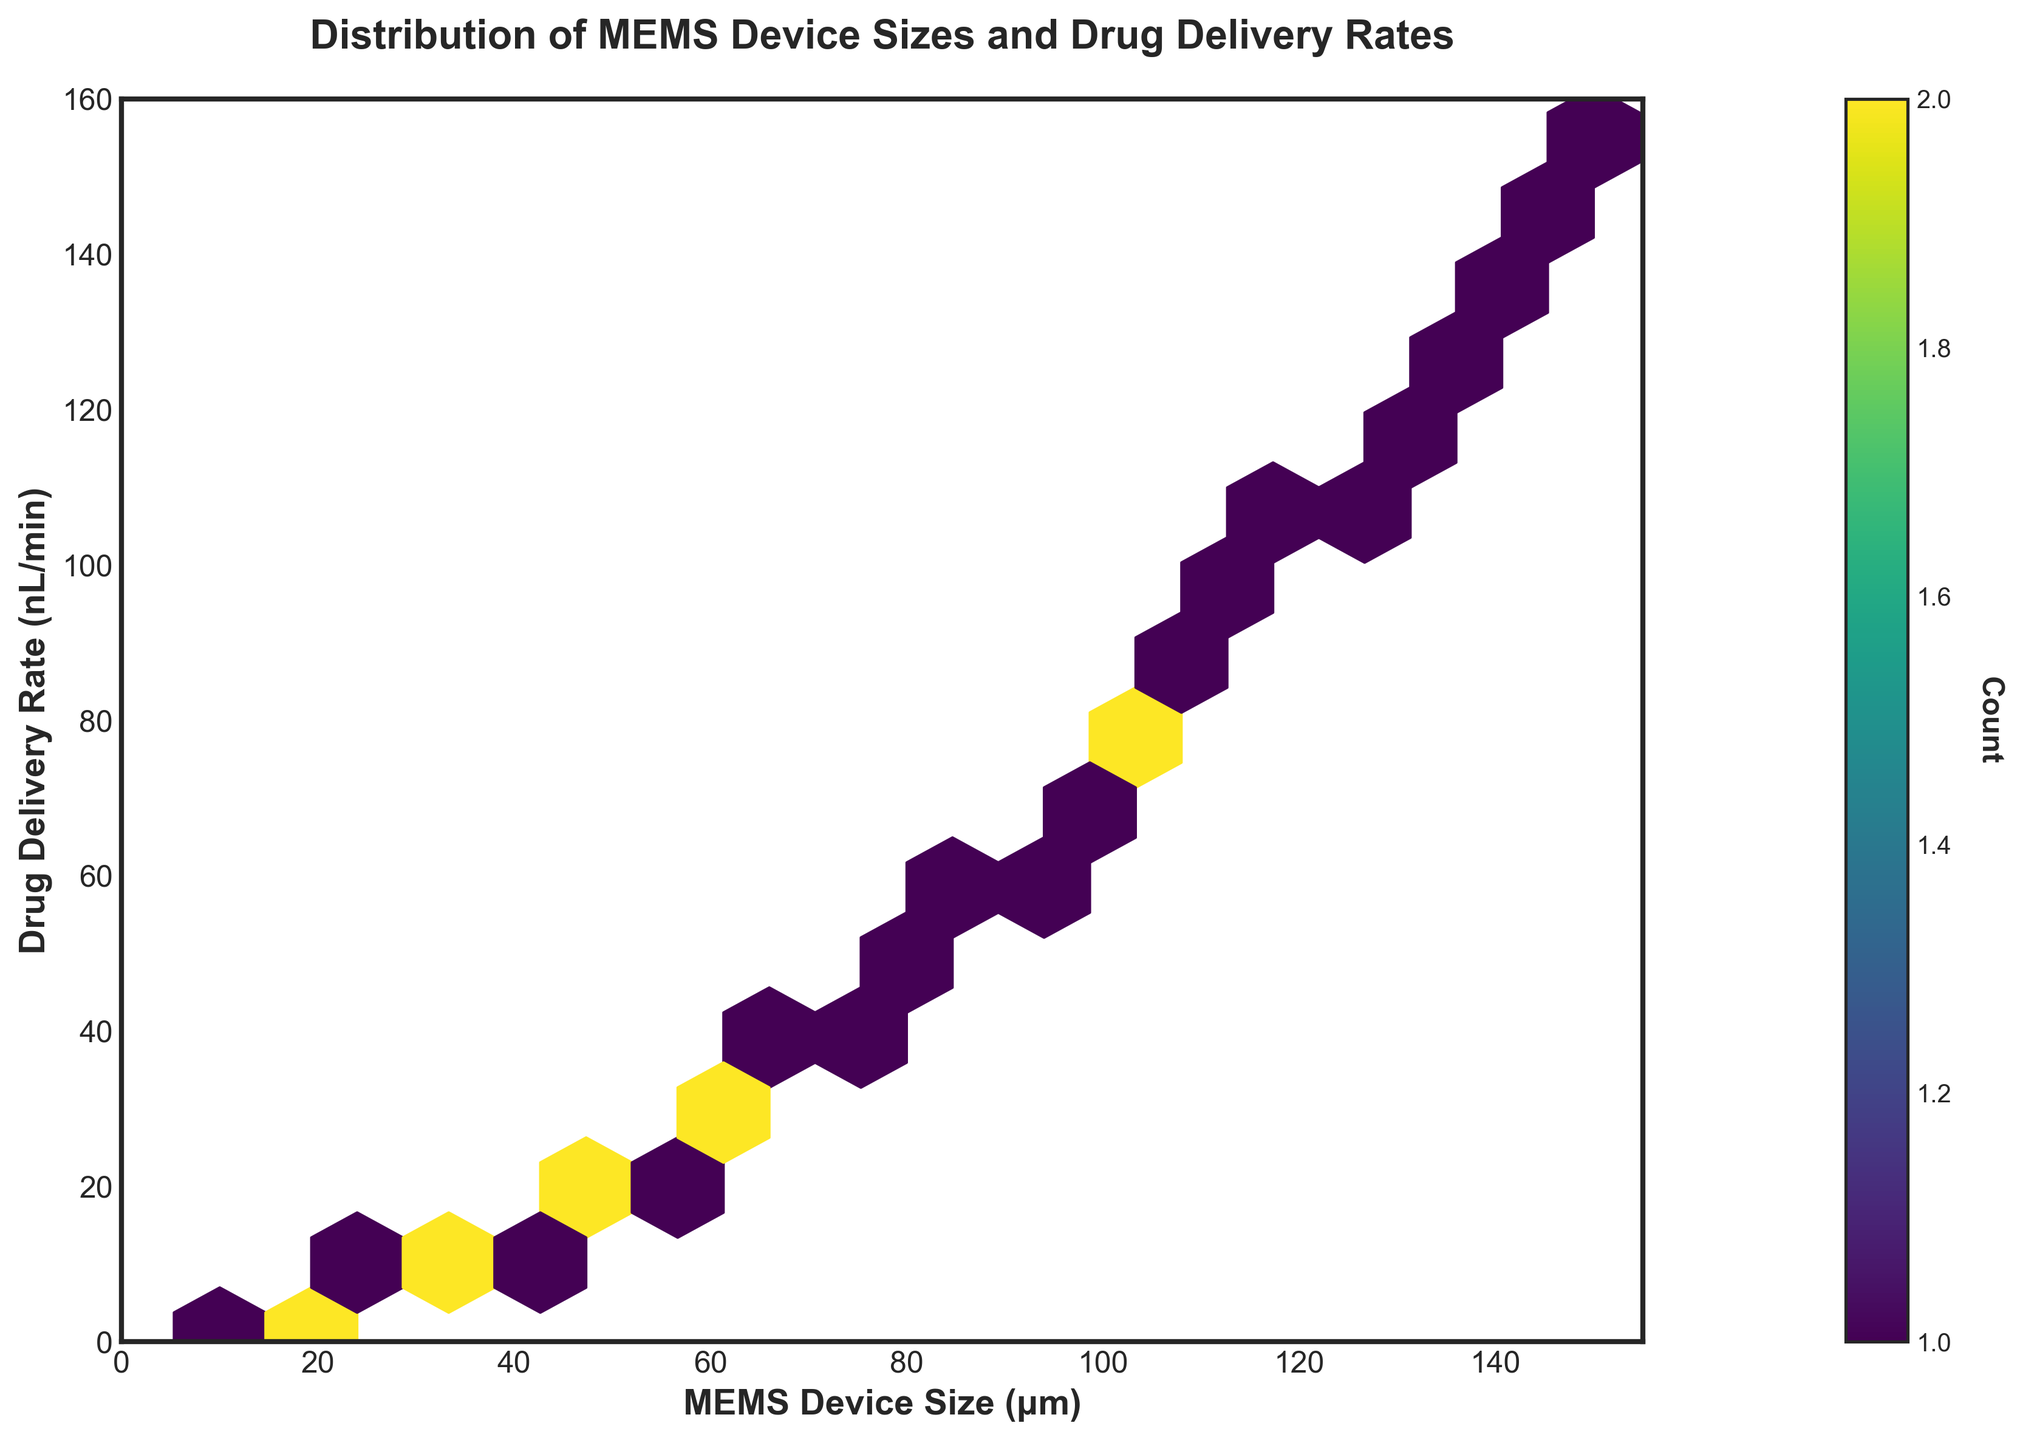What is the title of the plot? The title is usually displayed at the top of the plot. In this case, the title reads "Distribution of MEMS Device Sizes and Drug Delivery Rates".
Answer: Distribution of MEMS Device Sizes and Drug Delivery Rates What are the labels on the axes? The x-axis label can be found horizontally along the bottom, and the y-axis label runs vertically along the side. Here, the x-axis is labeled "MEMS Device Size (μm)" and the y-axis is labeled "Drug Delivery Rate (nL/min)".
Answer: MEMS Device Size (μm) and Drug Delivery Rate (nL/min) What is the color used for the hexbins, and what does it represent? The color map used is viridis, which displays a range from dark blue to bright yellow. The color intensity represents the count of data points within each hexbin.
Answer: Viridis, representing the count of data points Which size and delivery rate combination is most common in this dataset? By observing the highest intensity color (bright yellow) in the hexbin plot, we can identify the hexbin with the highest count. Let's assume it's around the size range of 50-55 μm and the rate range of 19-24 nL/min.
Answer: Around 50-55 μm and 19-24 nL/min Is there a general trend in the relationship between MEMS device size and drug delivery rate? The plot shows a progressive increase in drug delivery rate as the MEMS device size increases, indicating a positive correlation.
Answer: Positive correlation What is the drug delivery rate when the MEMS device size is about 100 μm? Locate the x-axis at approximately 100 μm and find the corresponding vertical range of the hexbin plot. The rate appears to be around 74.5 nL/min.
Answer: Around 74.5 nL/min Which is higher, the drug delivery rate for 30 μm or for 90 μm MEMS devices? Compare the vertical positions corresponding to 30 μm and 90 μm on the x-axis. The rate for 90 μm (around 61.3 nL/min) is higher than for 30 μm (around 6.7 nL/min).
Answer: 90 μm What can you say about the count of devices at different sizes? By looking at the color intensity throughout the hexbin plot, we observe that lower sizes have lighter colors (fewer counts), while some intermediate sizes show higher counts as indicated by darker colors.
Answer: Intermediate sizes have higher counts How does drug delivery rate change for MEMS device sizes beyond 120 μm? Observing the trend of the plot, the drug delivery rate continues to increase but seems to do so at a steady or slightly higher rate as the size increases beyond 120 μm.
Answer: Increases steadily or slightly higher Where is the color bar placed, and what does it indicate? The color bar is positioned to the right of the plot, providing a scale for the count of data points within each hexbin, ranging from low (dark color) to high (bright color) counts.
Answer: Right, indicating data point count 